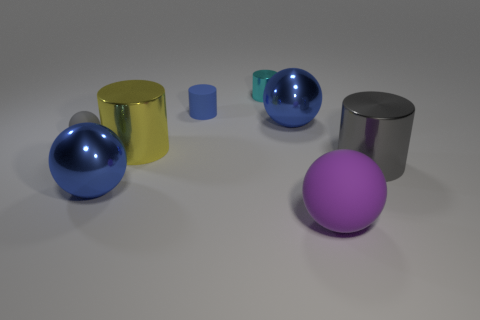There is a small matte ball; is its color the same as the large cylinder that is right of the blue cylinder?
Provide a succinct answer. Yes. Do the yellow cylinder and the tiny cylinder that is behind the blue cylinder have the same material?
Your answer should be very brief. Yes. How many objects are blue shiny things that are on the right side of the big yellow cylinder or small cylinders?
Ensure brevity in your answer.  3. Is there a metal object of the same color as the small matte cylinder?
Provide a short and direct response. Yes. There is a purple rubber object; is it the same shape as the big blue shiny object behind the large yellow shiny cylinder?
Give a very brief answer. Yes. What number of spheres are behind the big purple object and in front of the small gray thing?
Ensure brevity in your answer.  1. There is a tiny blue object that is the same shape as the big yellow shiny thing; what is it made of?
Ensure brevity in your answer.  Rubber. There is a blue shiny thing that is behind the large blue metallic sphere that is in front of the tiny gray matte thing; what size is it?
Offer a terse response. Large. Are there any big blue objects?
Ensure brevity in your answer.  Yes. There is a small object that is both in front of the cyan metallic cylinder and on the right side of the small sphere; what is its material?
Keep it short and to the point. Rubber. 